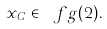<formula> <loc_0><loc_0><loc_500><loc_500>x _ { C } \in \ f g ( 2 ) .</formula> 